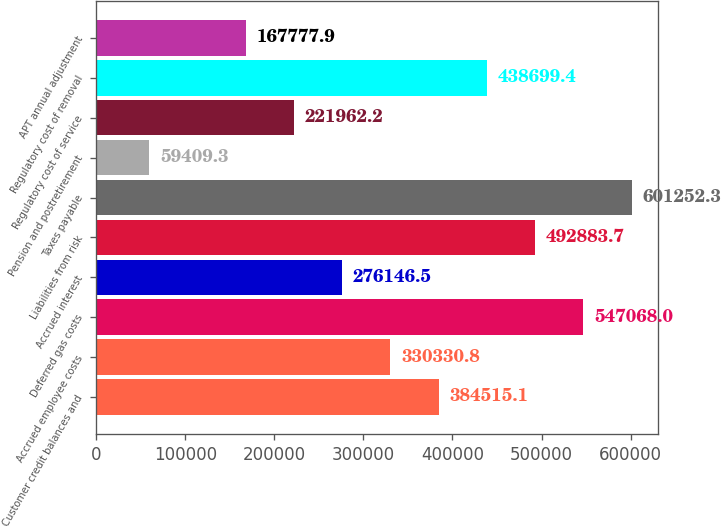<chart> <loc_0><loc_0><loc_500><loc_500><bar_chart><fcel>Customer credit balances and<fcel>Accrued employee costs<fcel>Deferred gas costs<fcel>Accrued interest<fcel>Liabilities from risk<fcel>Taxes payable<fcel>Pension and postretirement<fcel>Regulatory cost of service<fcel>Regulatory cost of removal<fcel>APT annual adjustment<nl><fcel>384515<fcel>330331<fcel>547068<fcel>276146<fcel>492884<fcel>601252<fcel>59409.3<fcel>221962<fcel>438699<fcel>167778<nl></chart> 